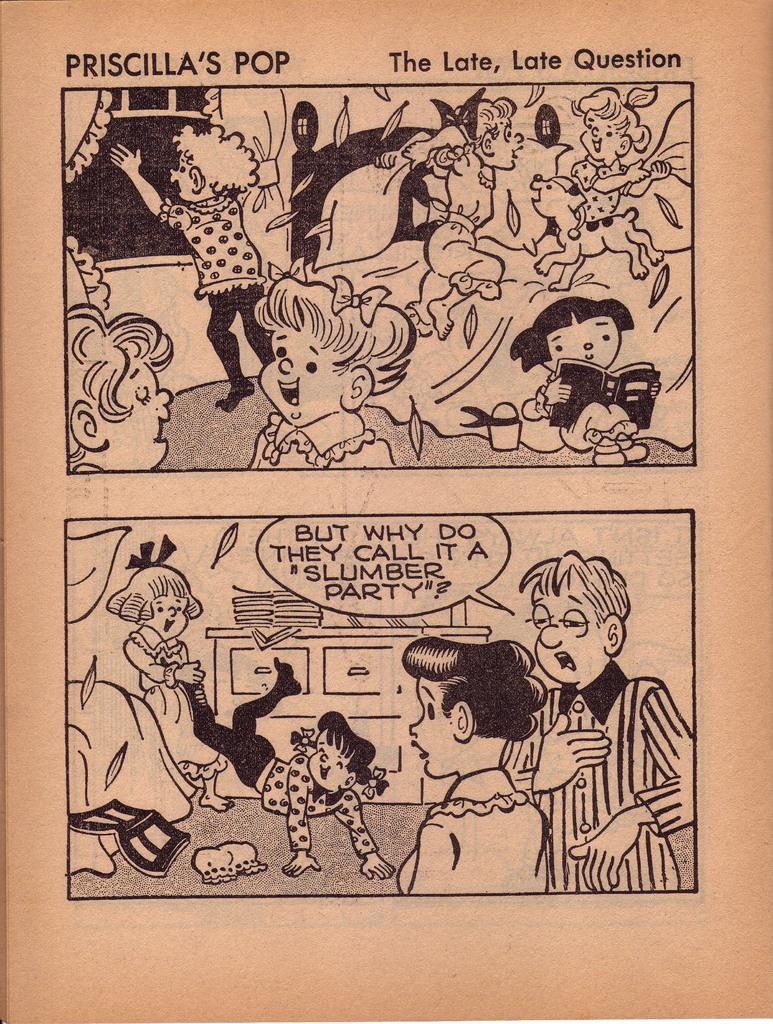<image>
Write a terse but informative summary of the picture. The Priscilla's Pop comic asks the question "But why do they call it a 'slumber party?' ". 